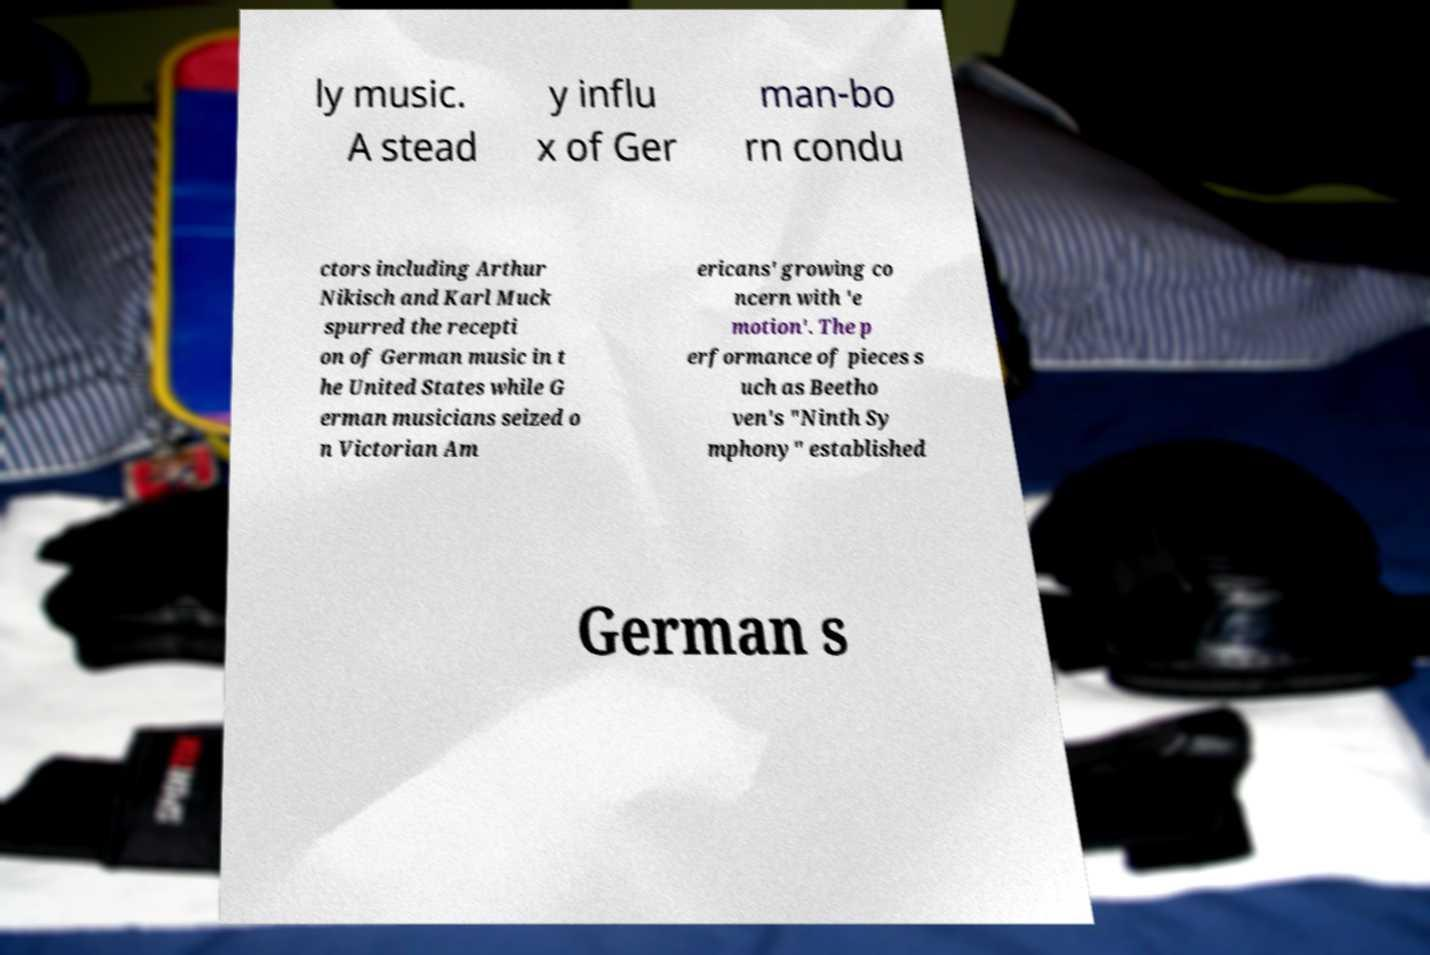What messages or text are displayed in this image? I need them in a readable, typed format. ly music. A stead y influ x of Ger man-bo rn condu ctors including Arthur Nikisch and Karl Muck spurred the recepti on of German music in t he United States while G erman musicians seized o n Victorian Am ericans' growing co ncern with 'e motion'. The p erformance of pieces s uch as Beetho ven's "Ninth Sy mphony" established German s 